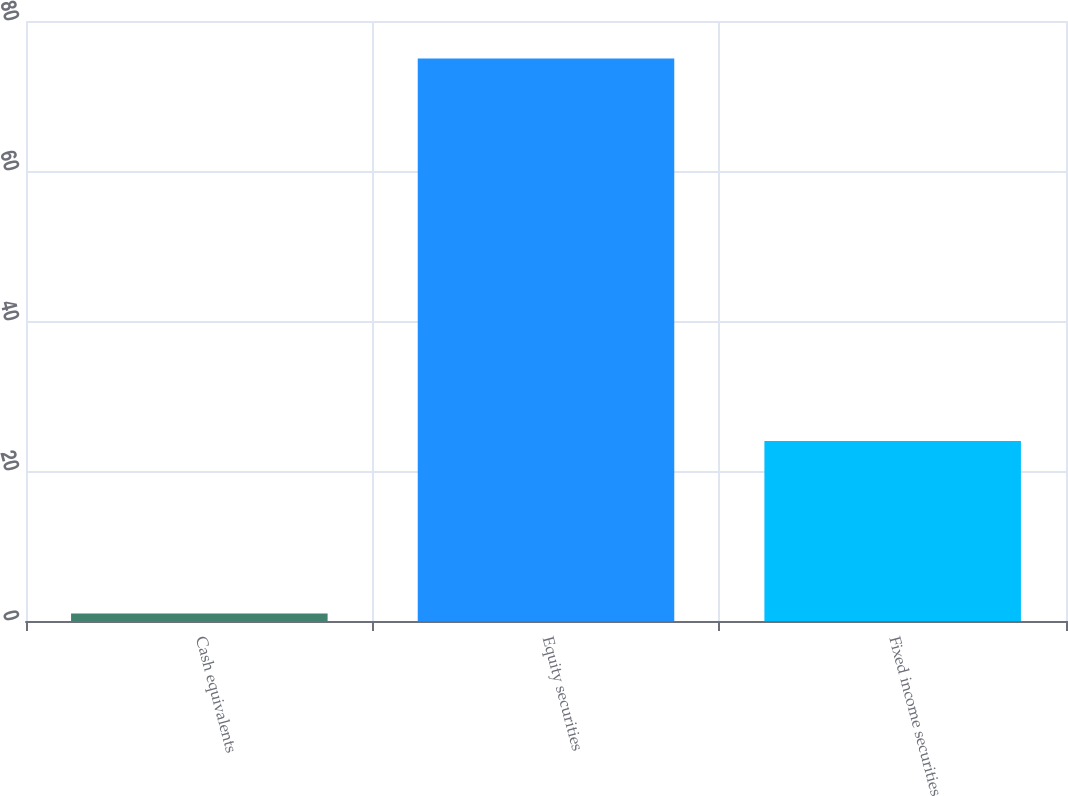Convert chart. <chart><loc_0><loc_0><loc_500><loc_500><bar_chart><fcel>Cash equivalents<fcel>Equity securities<fcel>Fixed income securities<nl><fcel>1<fcel>75<fcel>24<nl></chart> 